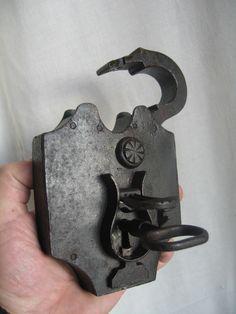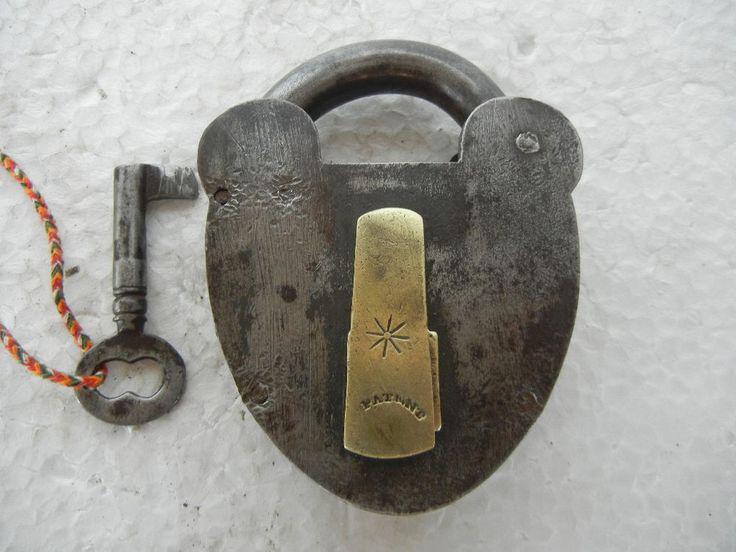The first image is the image on the left, the second image is the image on the right. Analyze the images presented: Is the assertion "An image shows one key on a colored string to the left of a vintage lock." valid? Answer yes or no. Yes. The first image is the image on the left, the second image is the image on the right. Analyze the images presented: Is the assertion "Both locks are in the lock position." valid? Answer yes or no. No. 